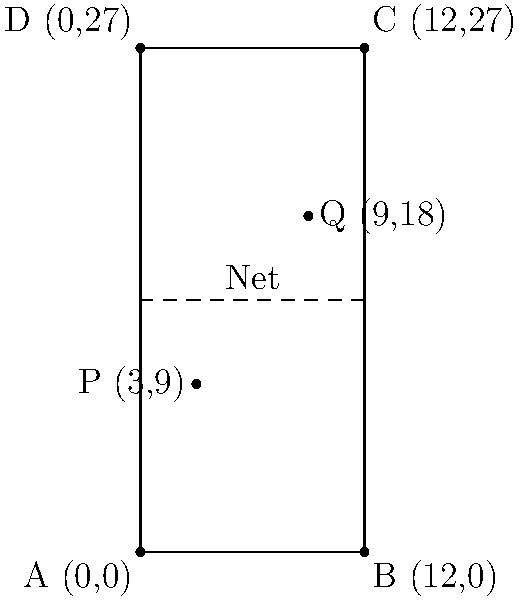On a tennis court represented by a coordinate system where each unit equals 1 meter, player P is positioned at (3,9) and player Q is at (9,18). Calculate the straight-line distance between the two players to the nearest tenth of a meter. To find the straight-line distance between two points, we can use the distance formula:

$d = \sqrt{(x_2 - x_1)^2 + (y_2 - y_1)^2}$

Where $(x_1, y_1)$ are the coordinates of the first point and $(x_2, y_2)$ are the coordinates of the second point.

Step 1: Identify the coordinates
Player P: $(x_1, y_1) = (3, 9)$
Player Q: $(x_2, y_2) = (9, 18)$

Step 2: Plug the values into the distance formula
$d = \sqrt{(9 - 3)^2 + (18 - 9)^2}$

Step 3: Simplify inside the parentheses
$d = \sqrt{6^2 + 9^2}$

Step 4: Calculate the squares
$d = \sqrt{36 + 81}$

Step 5: Add under the square root
$d = \sqrt{117}$

Step 6: Calculate the square root and round to the nearest tenth
$d \approx 10.8$ meters
Answer: 10.8 meters 